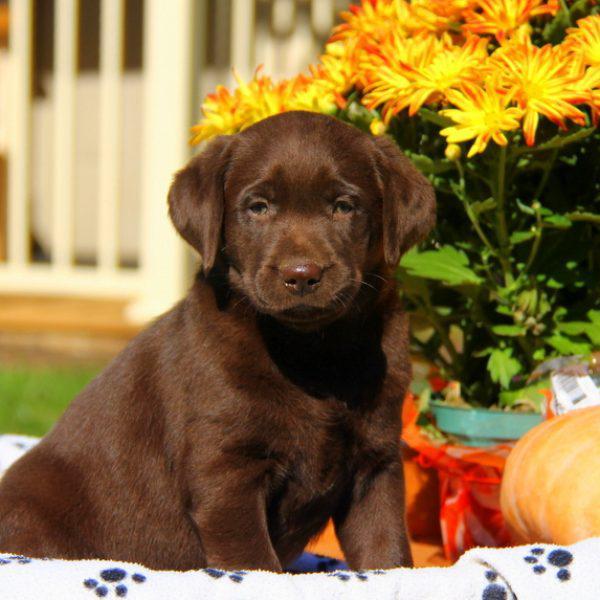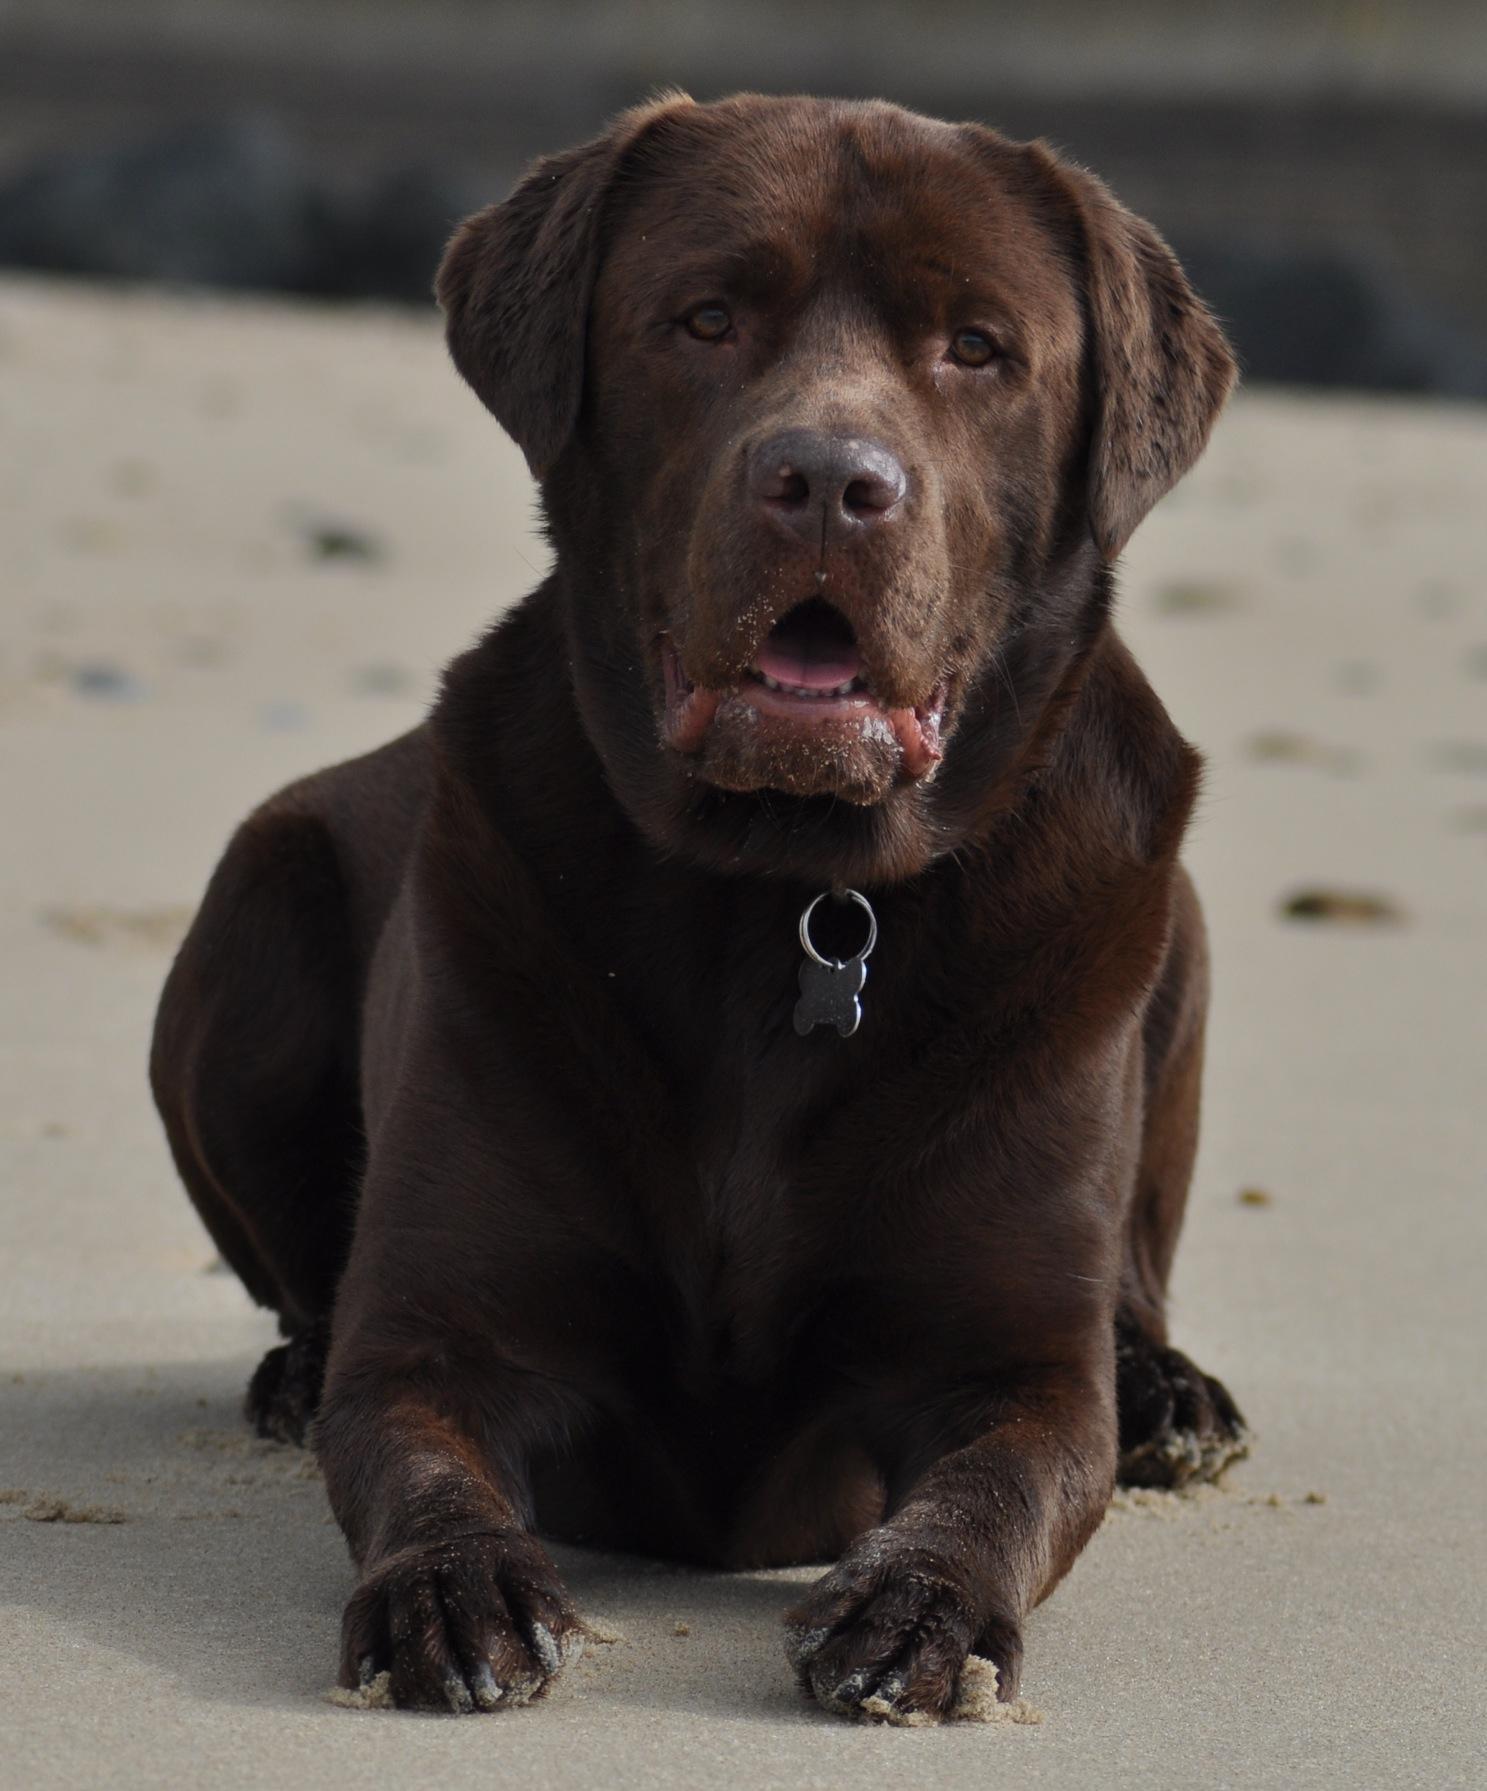The first image is the image on the left, the second image is the image on the right. For the images shown, is this caption "There are no fewer than three dogs in one of the images." true? Answer yes or no. No. The first image is the image on the left, the second image is the image on the right. Analyze the images presented: Is the assertion "One image features at least three dogs posed in a row." valid? Answer yes or no. No. 